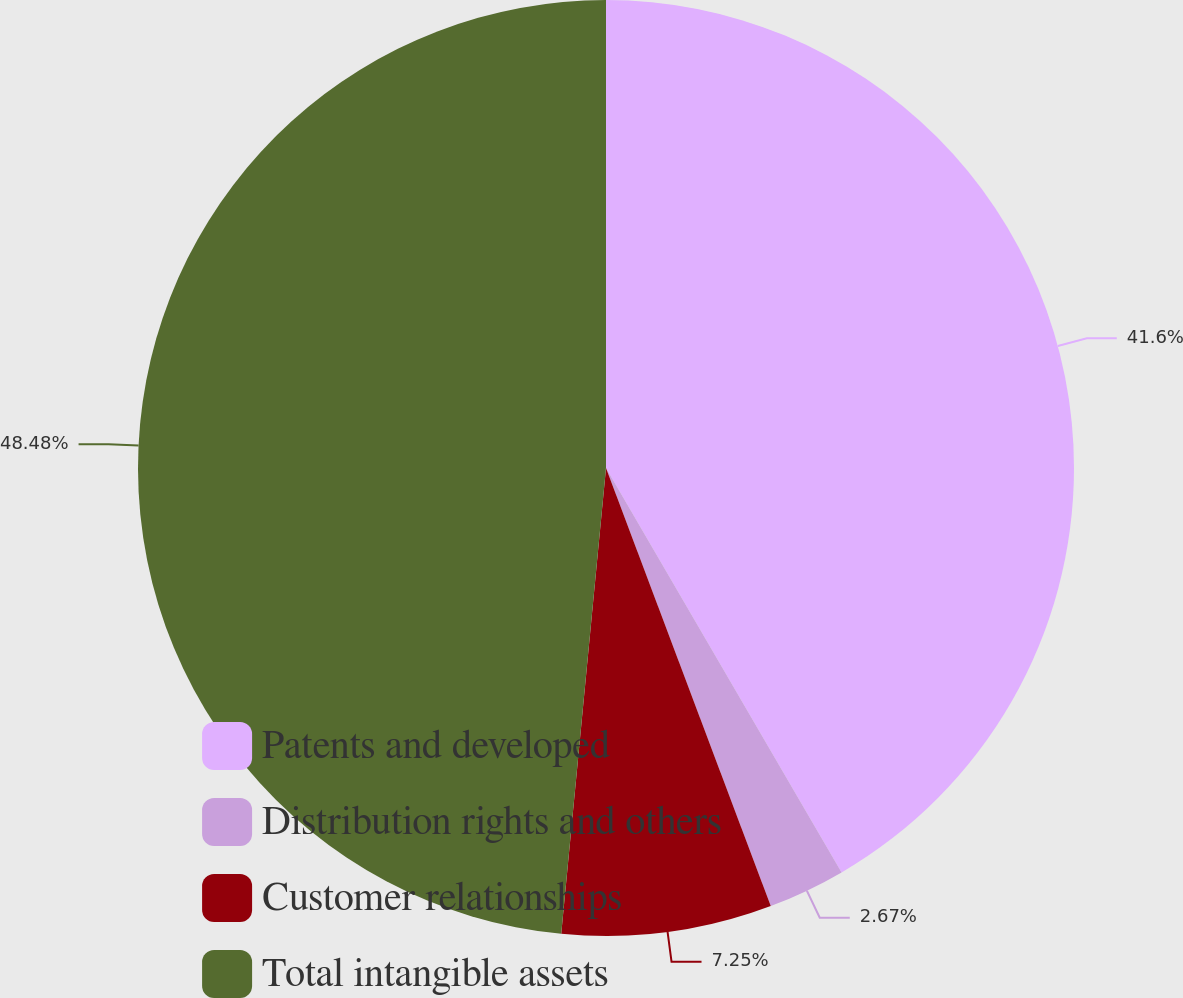Convert chart to OTSL. <chart><loc_0><loc_0><loc_500><loc_500><pie_chart><fcel>Patents and developed<fcel>Distribution rights and others<fcel>Customer relationships<fcel>Total intangible assets<nl><fcel>41.6%<fcel>2.67%<fcel>7.25%<fcel>48.47%<nl></chart> 